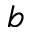<formula> <loc_0><loc_0><loc_500><loc_500>^ { b }</formula> 